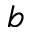<formula> <loc_0><loc_0><loc_500><loc_500>^ { b }</formula> 